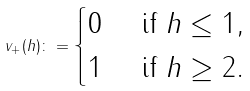<formula> <loc_0><loc_0><loc_500><loc_500>v _ { + } ( h ) \colon = \begin{cases} 0 & \text { if } h \leq 1 , \\ 1 & \text { if } h \geq 2 . \end{cases}</formula> 